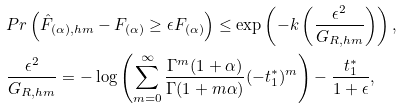Convert formula to latex. <formula><loc_0><loc_0><loc_500><loc_500>& P r \left ( \hat { F } _ { ( \alpha ) , h m } - F _ { ( \alpha ) } \geq \epsilon F _ { ( \alpha ) } \right ) \leq \exp \left ( - k \left ( \frac { \epsilon ^ { 2 } } { G _ { R , h m } } \right ) \right ) , \\ & \frac { \epsilon ^ { 2 } } { G _ { R , h m } } = - \log \left ( \sum _ { m = 0 } ^ { \infty } \frac { \Gamma ^ { m } ( 1 + \alpha ) } { \Gamma ( 1 + m \alpha ) } ( - t _ { 1 } ^ { * } ) ^ { m } \right ) - \frac { t _ { 1 } ^ { * } } { 1 + \epsilon } ,</formula> 